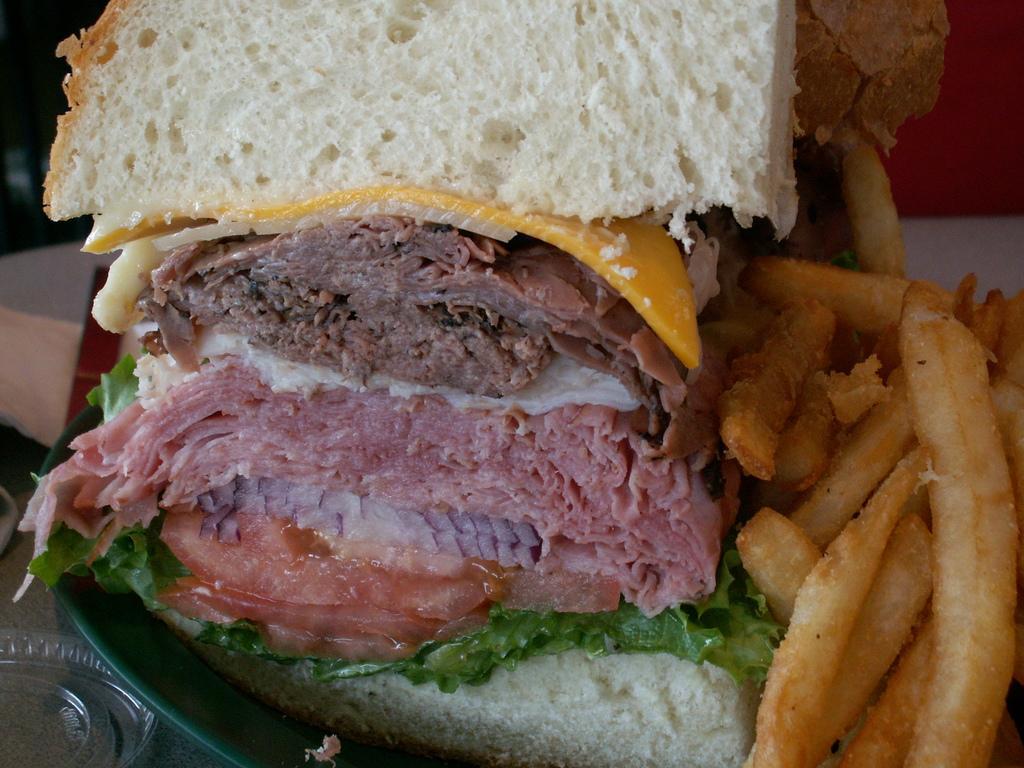Can you describe this image briefly? In the foreground of the image we can see food items in a plate. 